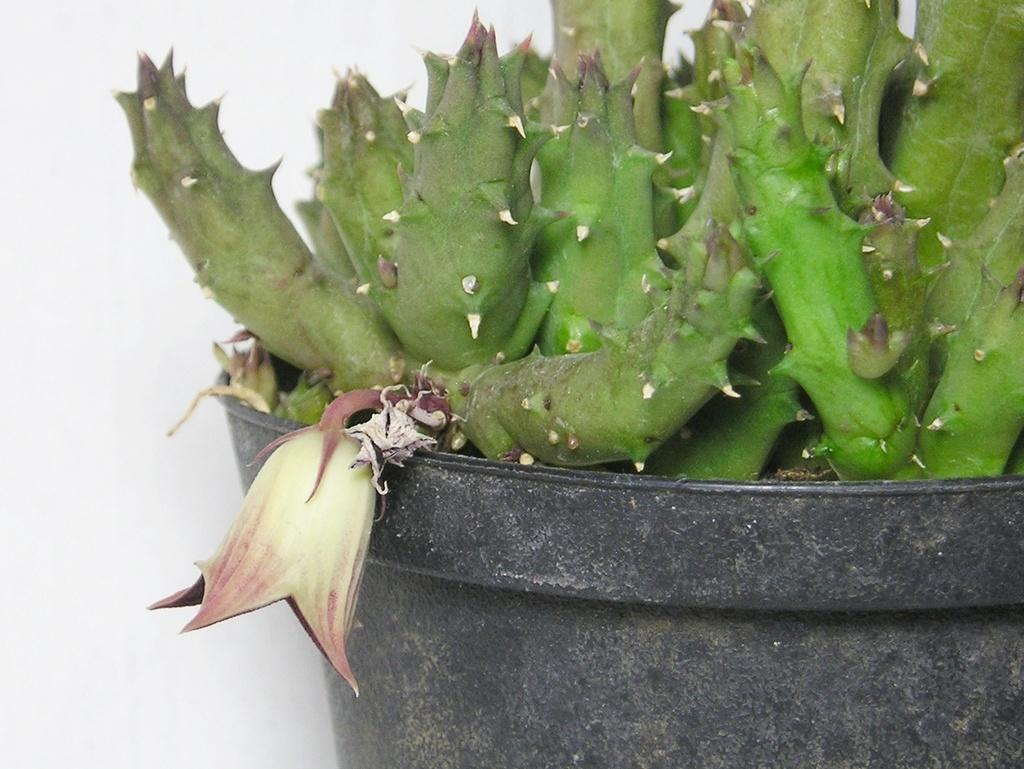What type of plants are in the image? There are green plants in the image. What color is the tub in which the plants are placed? The tub is black in color. What type of food is being prepared on the island in the image? There is no island or food preparation visible in the image; it only features green plants in a black tub. 